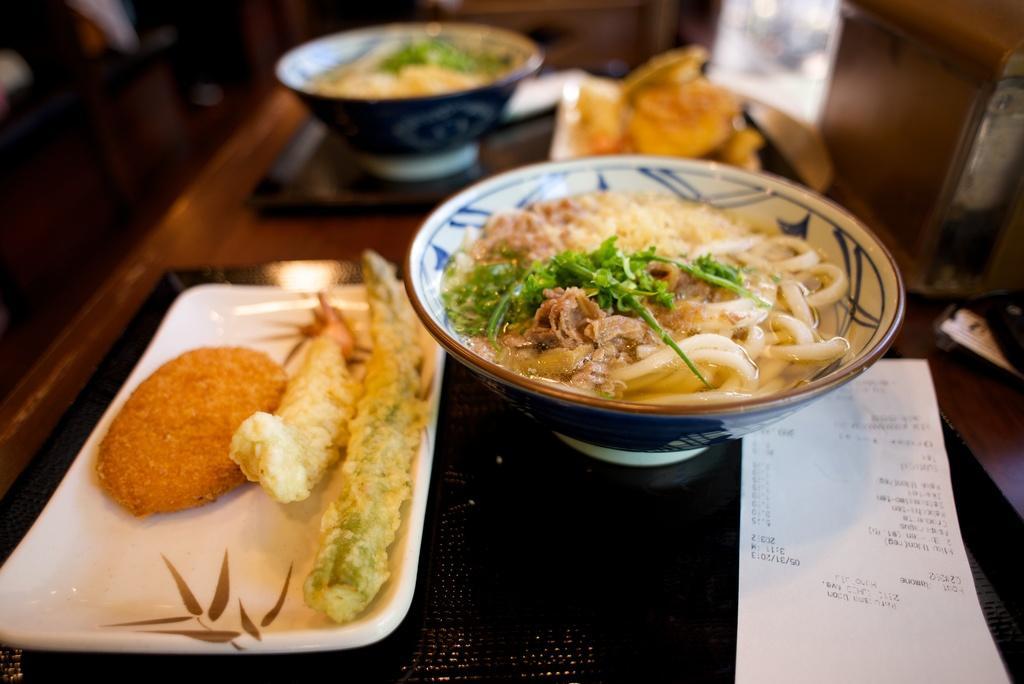Describe this image in one or two sentences. In this image we can see two bowls with food, two plates with food, one paper with text, some objects on the table, some objects on the floor and the background is blurred. 